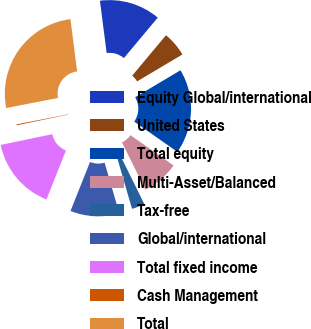Convert chart. <chart><loc_0><loc_0><loc_500><loc_500><pie_chart><fcel>Equity Global/international<fcel>United States<fcel>Total equity<fcel>Multi-Asset/Balanced<fcel>Tax-free<fcel>Global/international<fcel>Total fixed income<fcel>Cash Management<fcel>Total<nl><fcel>13.12%<fcel>5.38%<fcel>18.28%<fcel>7.96%<fcel>2.79%<fcel>10.54%<fcel>15.7%<fcel>0.21%<fcel>26.02%<nl></chart> 